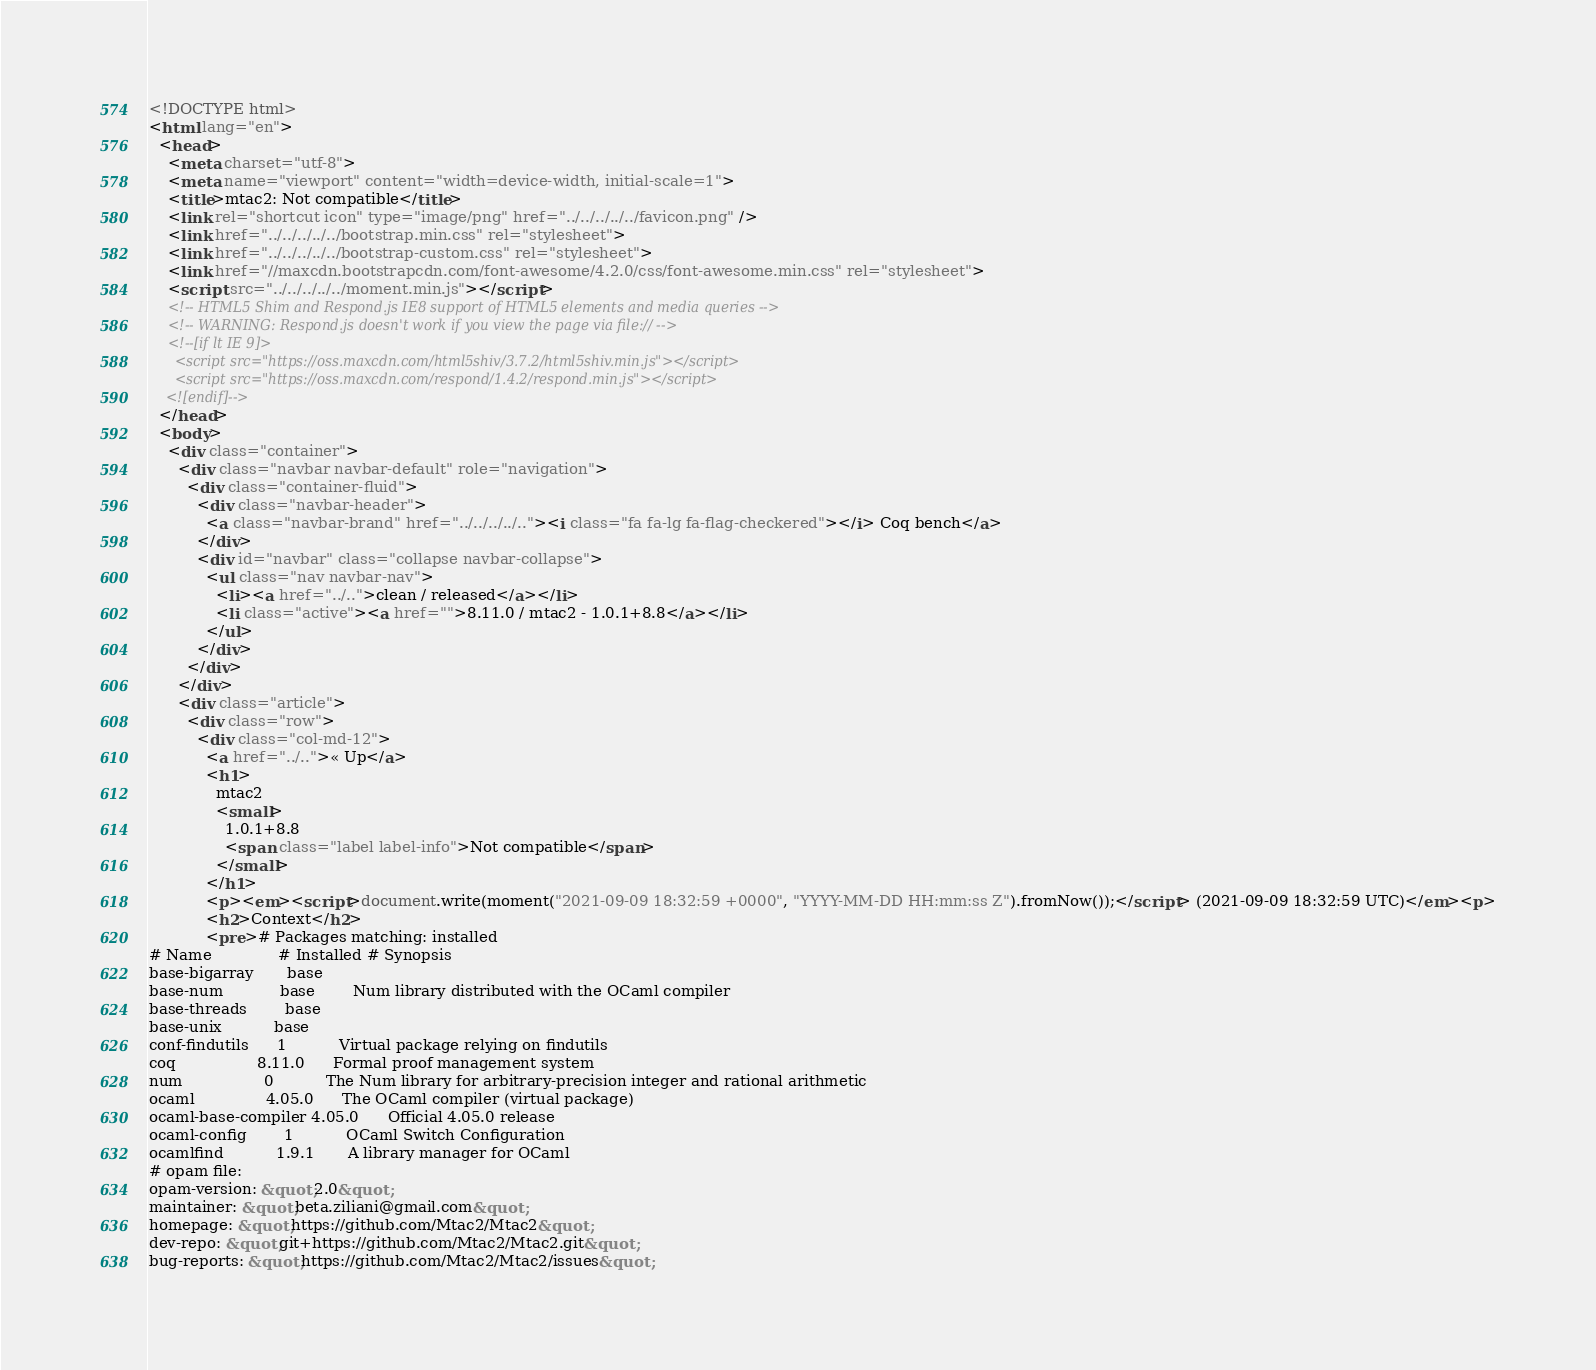Convert code to text. <code><loc_0><loc_0><loc_500><loc_500><_HTML_><!DOCTYPE html>
<html lang="en">
  <head>
    <meta charset="utf-8">
    <meta name="viewport" content="width=device-width, initial-scale=1">
    <title>mtac2: Not compatible</title>
    <link rel="shortcut icon" type="image/png" href="../../../../../favicon.png" />
    <link href="../../../../../bootstrap.min.css" rel="stylesheet">
    <link href="../../../../../bootstrap-custom.css" rel="stylesheet">
    <link href="//maxcdn.bootstrapcdn.com/font-awesome/4.2.0/css/font-awesome.min.css" rel="stylesheet">
    <script src="../../../../../moment.min.js"></script>
    <!-- HTML5 Shim and Respond.js IE8 support of HTML5 elements and media queries -->
    <!-- WARNING: Respond.js doesn't work if you view the page via file:// -->
    <!--[if lt IE 9]>
      <script src="https://oss.maxcdn.com/html5shiv/3.7.2/html5shiv.min.js"></script>
      <script src="https://oss.maxcdn.com/respond/1.4.2/respond.min.js"></script>
    <![endif]-->
  </head>
  <body>
    <div class="container">
      <div class="navbar navbar-default" role="navigation">
        <div class="container-fluid">
          <div class="navbar-header">
            <a class="navbar-brand" href="../../../../.."><i class="fa fa-lg fa-flag-checkered"></i> Coq bench</a>
          </div>
          <div id="navbar" class="collapse navbar-collapse">
            <ul class="nav navbar-nav">
              <li><a href="../..">clean / released</a></li>
              <li class="active"><a href="">8.11.0 / mtac2 - 1.0.1+8.8</a></li>
            </ul>
          </div>
        </div>
      </div>
      <div class="article">
        <div class="row">
          <div class="col-md-12">
            <a href="../..">« Up</a>
            <h1>
              mtac2
              <small>
                1.0.1+8.8
                <span class="label label-info">Not compatible</span>
              </small>
            </h1>
            <p><em><script>document.write(moment("2021-09-09 18:32:59 +0000", "YYYY-MM-DD HH:mm:ss Z").fromNow());</script> (2021-09-09 18:32:59 UTC)</em><p>
            <h2>Context</h2>
            <pre># Packages matching: installed
# Name              # Installed # Synopsis
base-bigarray       base
base-num            base        Num library distributed with the OCaml compiler
base-threads        base
base-unix           base
conf-findutils      1           Virtual package relying on findutils
coq                 8.11.0      Formal proof management system
num                 0           The Num library for arbitrary-precision integer and rational arithmetic
ocaml               4.05.0      The OCaml compiler (virtual package)
ocaml-base-compiler 4.05.0      Official 4.05.0 release
ocaml-config        1           OCaml Switch Configuration
ocamlfind           1.9.1       A library manager for OCaml
# opam file:
opam-version: &quot;2.0&quot;
maintainer: &quot;beta.ziliani@gmail.com&quot;
homepage: &quot;https://github.com/Mtac2/Mtac2&quot;
dev-repo: &quot;git+https://github.com/Mtac2/Mtac2.git&quot;
bug-reports: &quot;https://github.com/Mtac2/Mtac2/issues&quot;</code> 